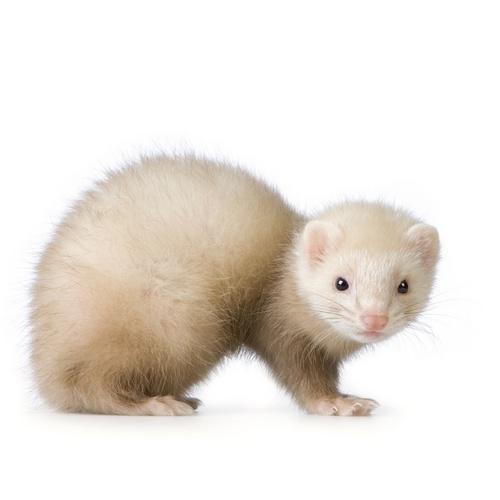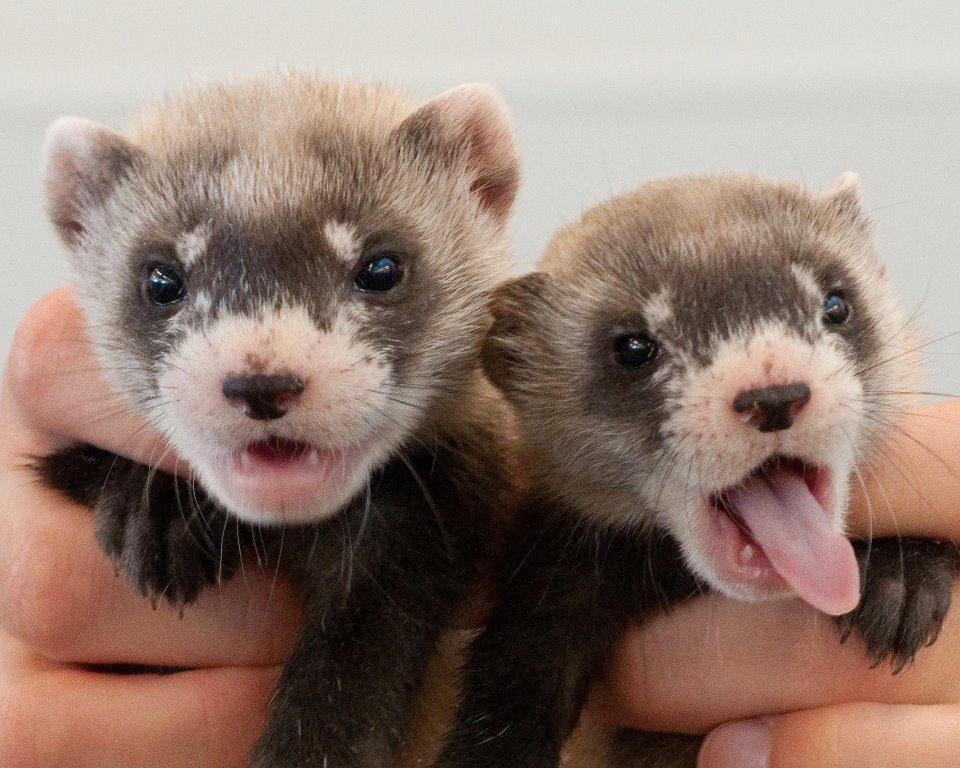The first image is the image on the left, the second image is the image on the right. Examine the images to the left and right. Is the description "The left image contains more ferrets than the right image." accurate? Answer yes or no. No. 